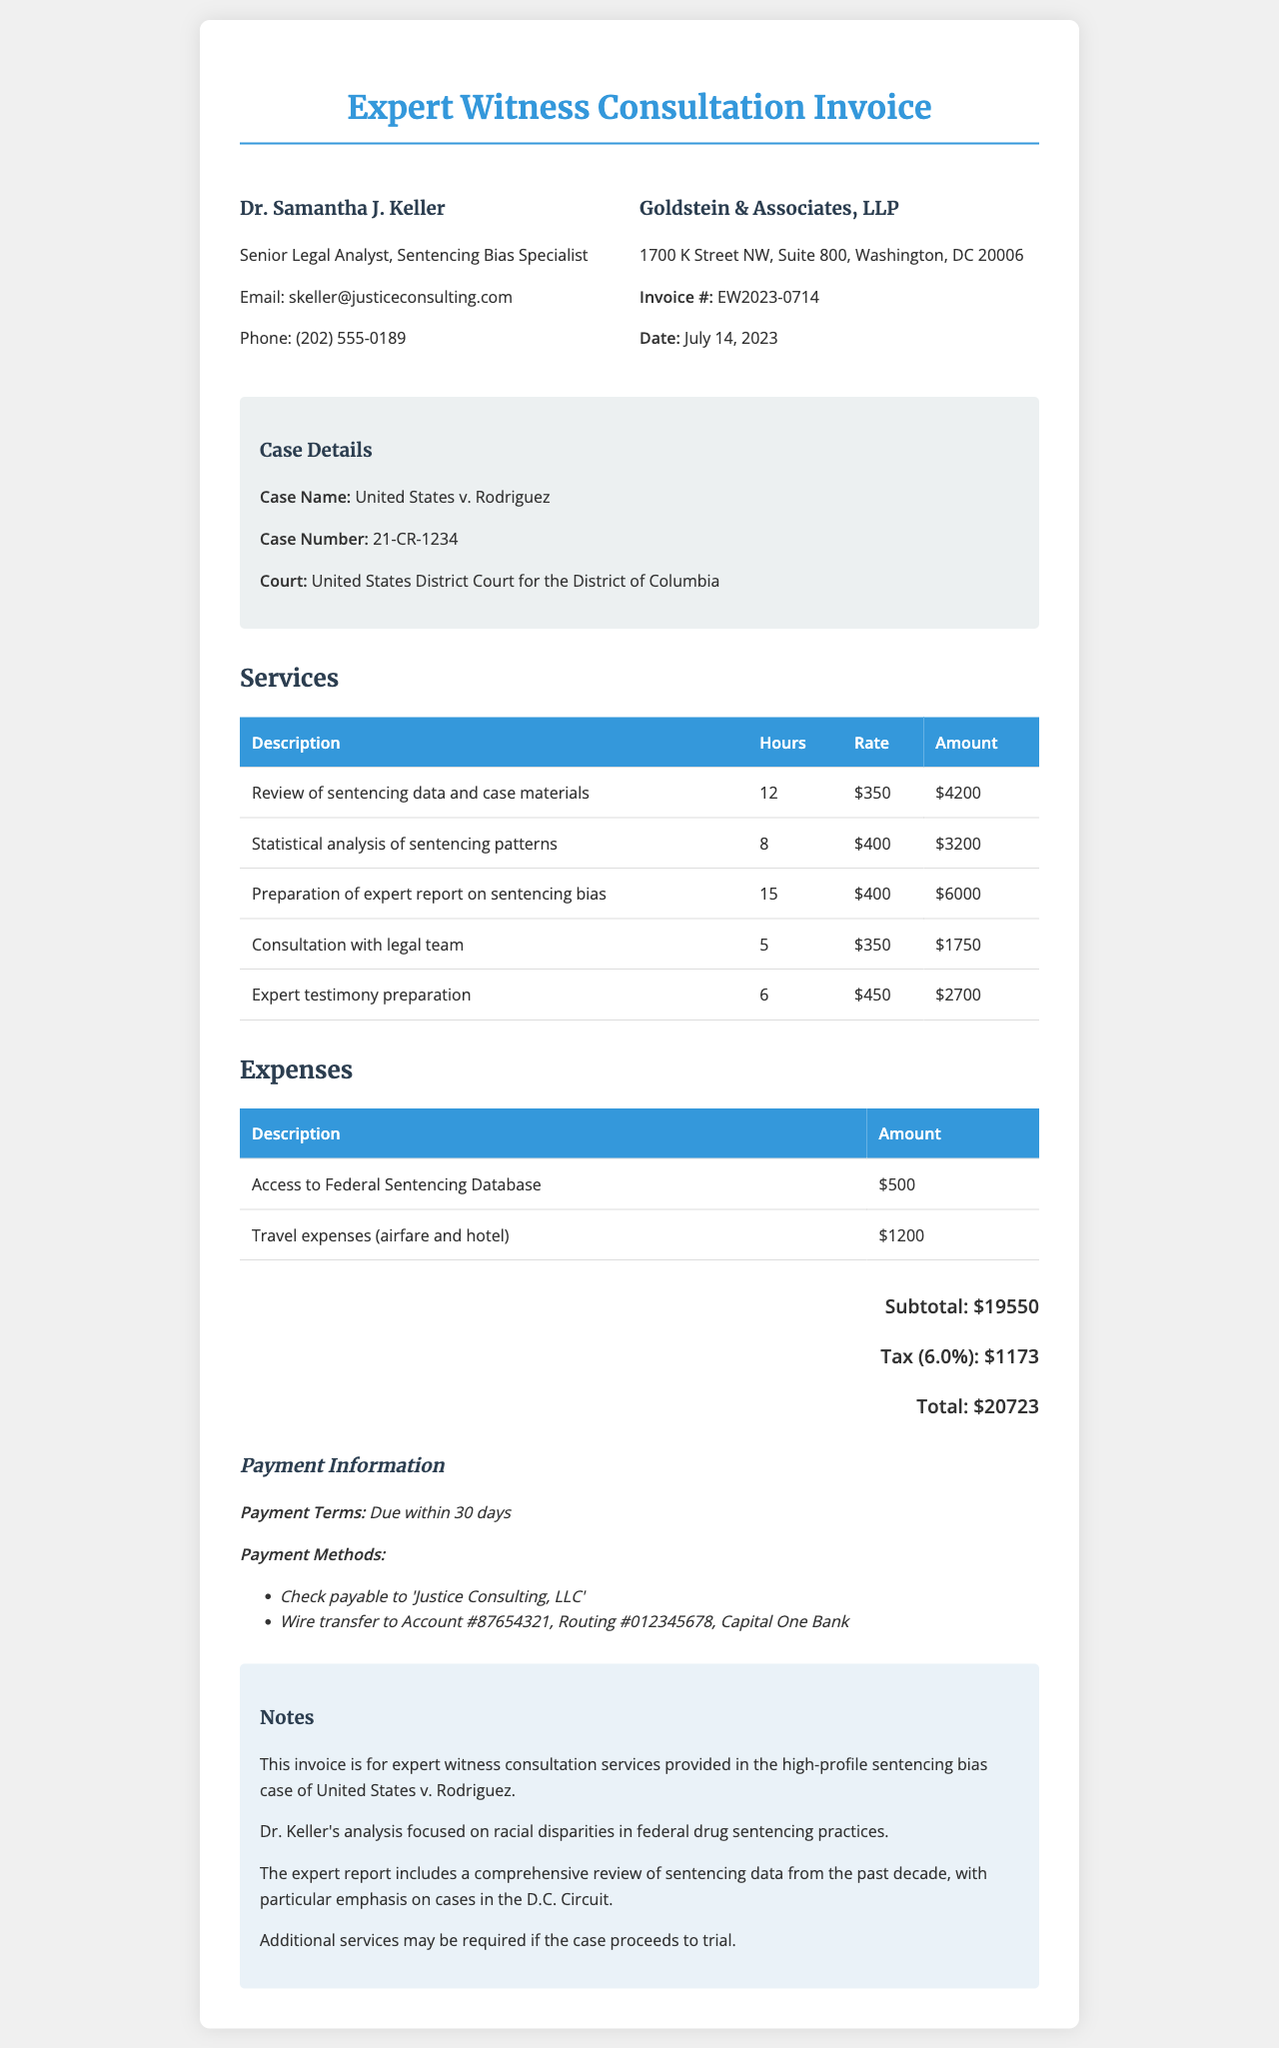What is the receipt number? The receipt number identifies this specific invoice for the consultation services.
Answer: EW2023-0714 Who is the expert witness? The expert witness is the individual providing consultation services for the case.
Answer: Dr. Samantha J. Keller What is the total amount due? The total amount reflects the sum of the services, expenses, subtotal, and tax.
Answer: $20,723 How many hours were billed for the preparation of the expert report on sentencing bias? This requires summing the hours related to the specific service in the document.
Answer: 15 What is the client's name? The client's name is the law firm that engaged the expert for consultation services.
Answer: Goldstein & Associates, LLP What was the tax rate applied to the subtotal? This percentage represents the tax applied to the subtotal amount in the invoice.
Answer: 6% What is one of the payment methods mentioned? This asks for an option provided for making the payment for the services rendered.
Answer: Check payable to 'Justice Consulting, LLC' How many hours were spent on consultation with the legal team? This is directly found next to the specific service description in the document.
Answer: 5 What type of case is being addressed in the invoice? This type refers to the legal matter that Dr. Keller's analysis concerns.
Answer: Sentencing bias case 